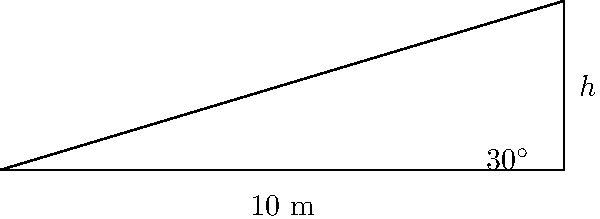As the city council member proposing a new skate park, you're working with engineers to design the perfect ramp. They've determined that a 30° angle provides the optimal slope for most skateboarders. If the base of the ramp is 10 meters long, what height (h) should the ramp be to achieve this optimal angle? Round your answer to the nearest tenth of a meter. To solve this problem, we'll use the tangent function from trigonometry. Here's the step-by-step solution:

1) In a right triangle, tangent of an angle is the ratio of the opposite side to the adjacent side.

2) In this case:
   - The angle is 30°
   - The adjacent side (base of the ramp) is 10 meters
   - We need to find the opposite side (height of the ramp)

3) Let's write the equation:
   $$\tan(30°) = \frac{h}{10}$$

4) We know that $\tan(30°) = \frac{1}{\sqrt{3}} \approx 0.577$

5) Substituting this value:
   $$0.577 = \frac{h}{10}$$

6) Multiply both sides by 10:
   $$10 * 0.577 = h$$

7) Calculate:
   $$h = 5.77 \text{ meters}$$

8) Rounding to the nearest tenth:
   $$h \approx 5.8 \text{ meters}$$

Therefore, the ramp should be approximately 5.8 meters high to achieve the optimal 30° angle with a 10-meter base.
Answer: 5.8 meters 